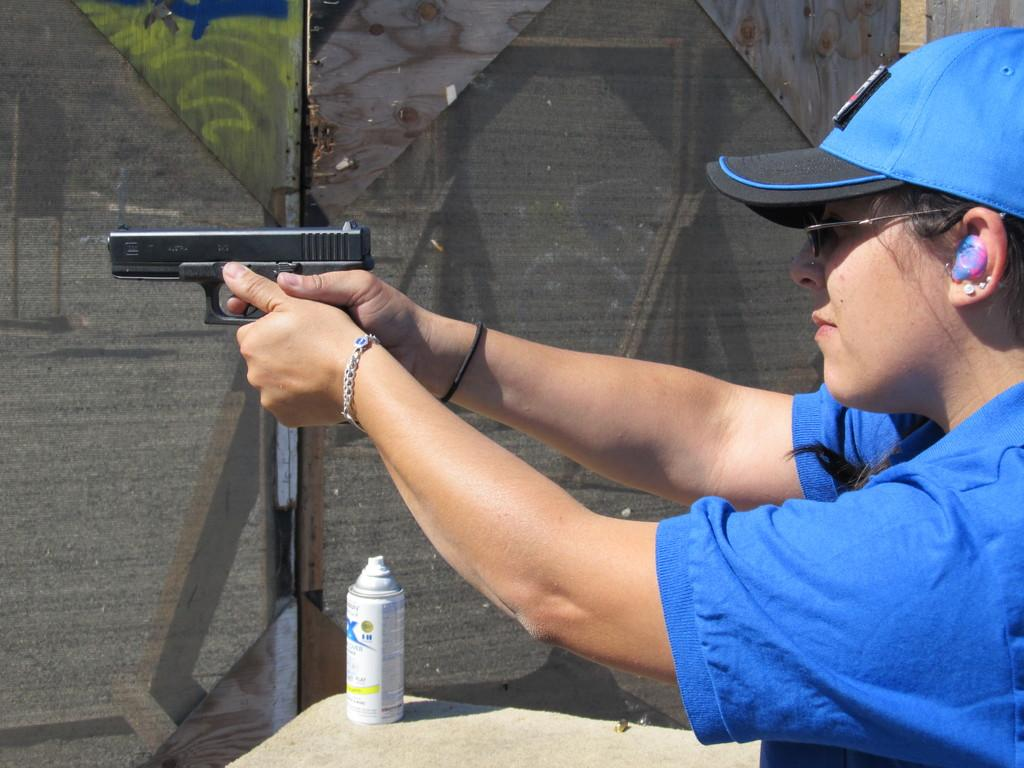Who is present in the image? There is a woman in the image. What is the woman holding in the image? The woman is holding a gun. What type of headwear is the woman wearing? The woman is wearing a cap. What object can be seen on a table in the image? There is a bottle on a table in the image. What can be seen in the background of the image? There is a fence in the background of the image. Is the woman wearing a crown in the image? No, the woman is not wearing a crown in the image; she is wearing a cap. Can you see any feathers in the image? No, there are no feathers present in the image. 